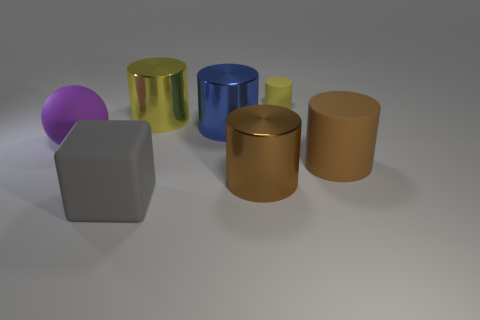Is the number of blocks behind the gray matte cube less than the number of large blue metal cylinders?
Ensure brevity in your answer.  Yes. Are there more gray matte blocks to the right of the large blue metallic cylinder than large purple objects in front of the big rubber sphere?
Your answer should be compact. No. Is there any other thing that has the same color as the big block?
Offer a very short reply. No. What is the material of the small yellow cylinder that is to the right of the sphere?
Your answer should be compact. Rubber. Is the size of the yellow rubber thing the same as the yellow shiny cylinder?
Your answer should be compact. No. What number of other objects are the same size as the brown metallic cylinder?
Ensure brevity in your answer.  5. Do the rubber ball and the rubber cube have the same color?
Your answer should be very brief. No. What is the shape of the yellow object right of the brown cylinder left of the large brown cylinder to the right of the yellow rubber object?
Offer a terse response. Cylinder. How many objects are yellow things that are behind the brown matte thing or objects that are behind the large rubber block?
Offer a very short reply. 6. What size is the brown object on the right side of the tiny yellow cylinder that is behind the big gray object?
Your answer should be very brief. Large. 